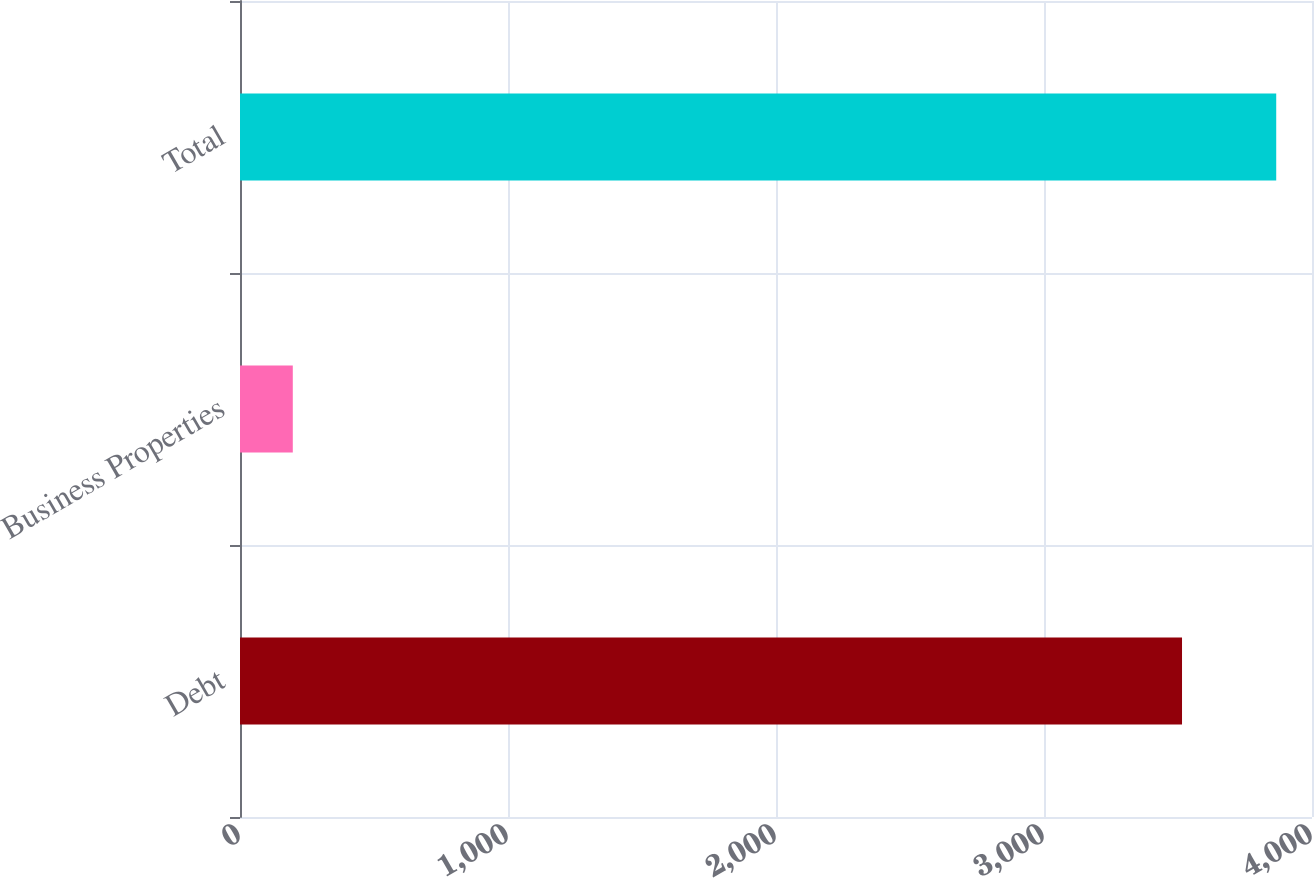Convert chart to OTSL. <chart><loc_0><loc_0><loc_500><loc_500><bar_chart><fcel>Debt<fcel>Business Properties<fcel>Total<nl><fcel>3515<fcel>197<fcel>3866.5<nl></chart> 